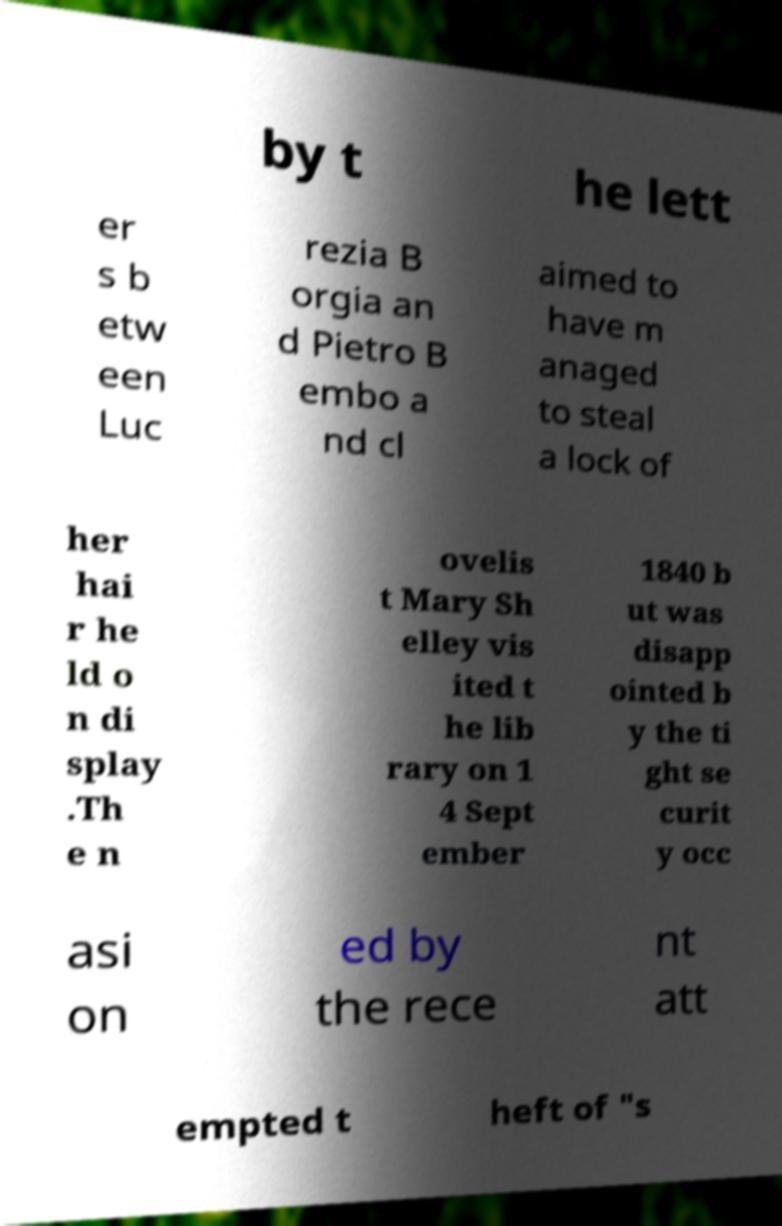Can you read and provide the text displayed in the image?This photo seems to have some interesting text. Can you extract and type it out for me? by t he lett er s b etw een Luc rezia B orgia an d Pietro B embo a nd cl aimed to have m anaged to steal a lock of her hai r he ld o n di splay .Th e n ovelis t Mary Sh elley vis ited t he lib rary on 1 4 Sept ember 1840 b ut was disapp ointed b y the ti ght se curit y occ asi on ed by the rece nt att empted t heft of "s 